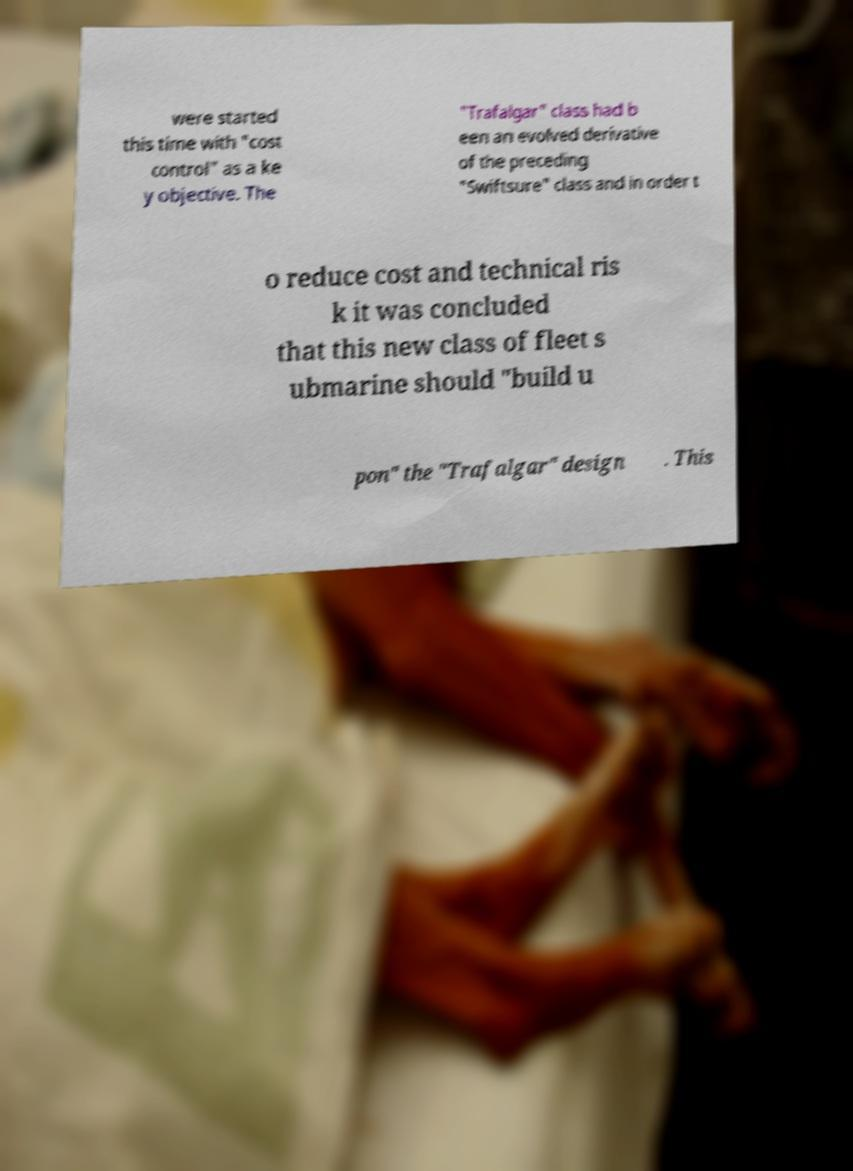Could you assist in decoding the text presented in this image and type it out clearly? were started this time with "cost control" as a ke y objective. The "Trafalgar" class had b een an evolved derivative of the preceding "Swiftsure" class and in order t o reduce cost and technical ris k it was concluded that this new class of fleet s ubmarine should "build u pon" the "Trafalgar" design . This 